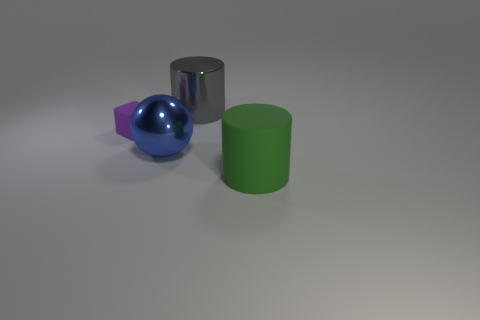How many other things are the same material as the gray object?
Provide a short and direct response. 1. There is a large rubber object; does it have the same color as the cylinder that is left of the big rubber cylinder?
Your answer should be very brief. No. Does the thing that is behind the purple block have the same size as the small rubber thing?
Your answer should be very brief. No. What is the material of the gray thing that is the same shape as the big green object?
Your response must be concise. Metal. Do the large matte object and the small object have the same shape?
Make the answer very short. No. How many large gray objects are behind the large metallic thing in front of the purple rubber object?
Provide a short and direct response. 1. There is a purple object that is the same material as the green thing; what is its shape?
Give a very brief answer. Cube. How many blue things are either shiny balls or blocks?
Give a very brief answer. 1. Are there any tiny purple matte cubes on the left side of the big thing that is left of the metal object behind the big blue metallic sphere?
Make the answer very short. Yes. Is the number of tiny rubber things less than the number of large yellow cubes?
Your answer should be very brief. No. 